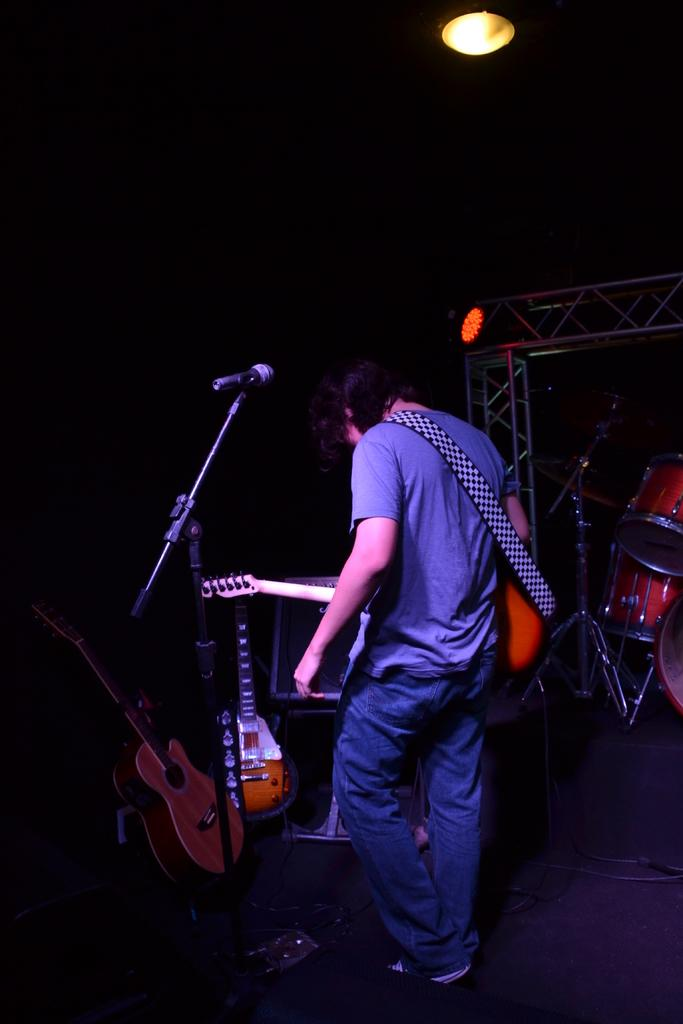Who is the person in the image? There is a man in the image. What is the man wearing? The man is wearing a blue dress. What is the man holding in the image? The man is holding a guitar. What is the man standing in front of? The man is standing in front of a microphone. What other musical instruments can be seen in the image? There are guitars and drums present in the image. What type of quilt is draped over the microphone in the image? There is no quilt present in the image; the man is standing in front of a microphone while holding a guitar. 